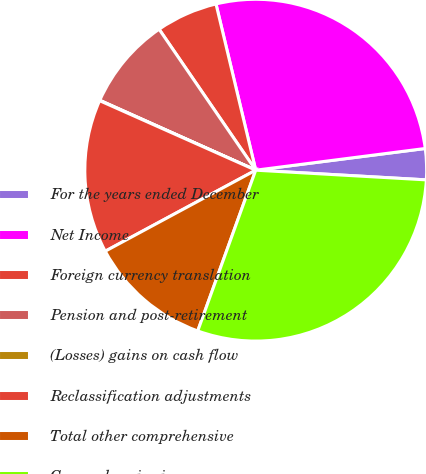Convert chart to OTSL. <chart><loc_0><loc_0><loc_500><loc_500><pie_chart><fcel>For the years ended December<fcel>Net Income<fcel>Foreign currency translation<fcel>Pension and post-retirement<fcel>(Losses) gains on cash flow<fcel>Reclassification adjustments<fcel>Total other comprehensive<fcel>Comprehensive income<nl><fcel>2.93%<fcel>26.71%<fcel>5.83%<fcel>8.73%<fcel>0.04%<fcel>14.53%<fcel>11.63%<fcel>29.61%<nl></chart> 